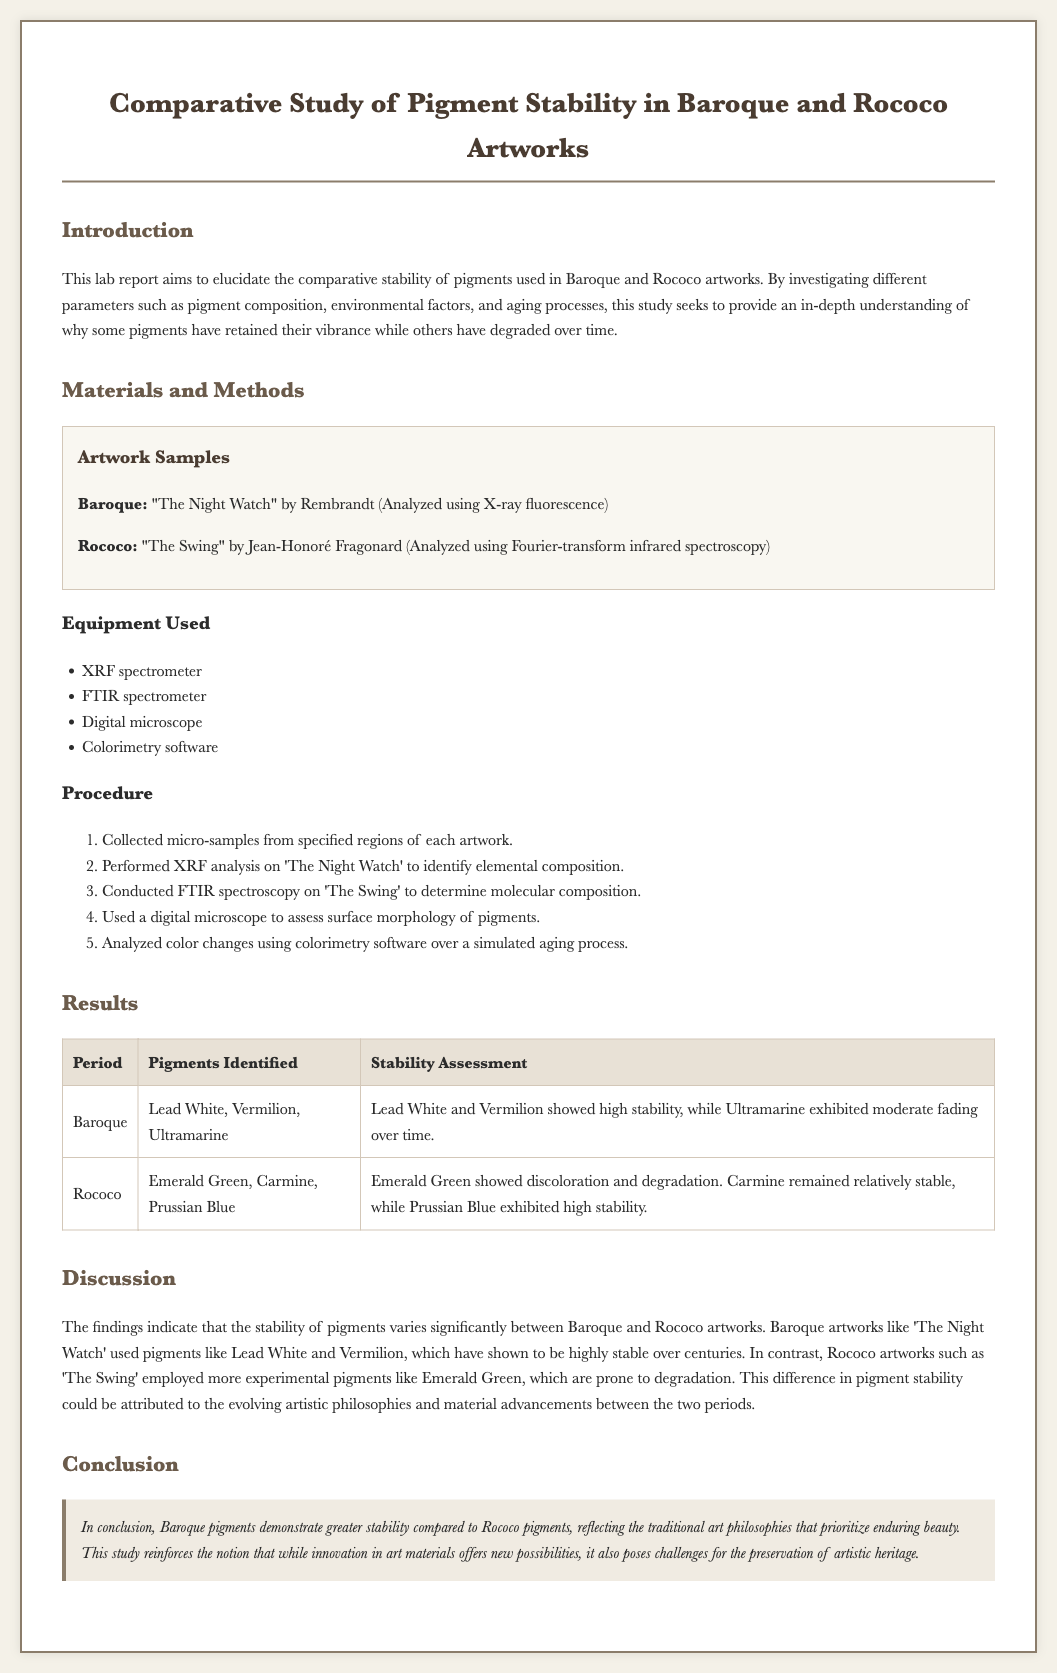what are the two periods studied in this report? The report focuses on two distinct artistic periods: Baroque and Rococo.
Answer: Baroque and Rococo which artwork was analyzed using X-ray fluorescence? The artwork analyzed using X-ray fluorescence was "The Night Watch" by Rembrandt.
Answer: "The Night Watch" what pigment showed high stability in Baroque artworks? Lead White and Vermilion showed high stability in Baroque artworks as per the results.
Answer: Lead White and Vermilion which pigment in Rococo artworks exhibited discoloration? The pigment that showed discoloration in Rococo artworks was Emerald Green.
Answer: Emerald Green how many equipment types were used in the analysis? Four types of equipment were listed for the analysis in the materials and methods section.
Answer: Four what is the conclusion regarding the stability of Baroque pigments? The conclusion states that Baroque pigments demonstrate greater stability compared to Rococo pigments.
Answer: Greater stability which analysis technique was used for "The Swing"? The analysis technique used for "The Swing" was Fourier-transform infrared spectroscopy.
Answer: Fourier-transform infrared spectroscopy which pigment in Rococo remained relatively stable? Carmine is noted to have remained relatively stable among the pigments in Rococo artworks.
Answer: Carmine 